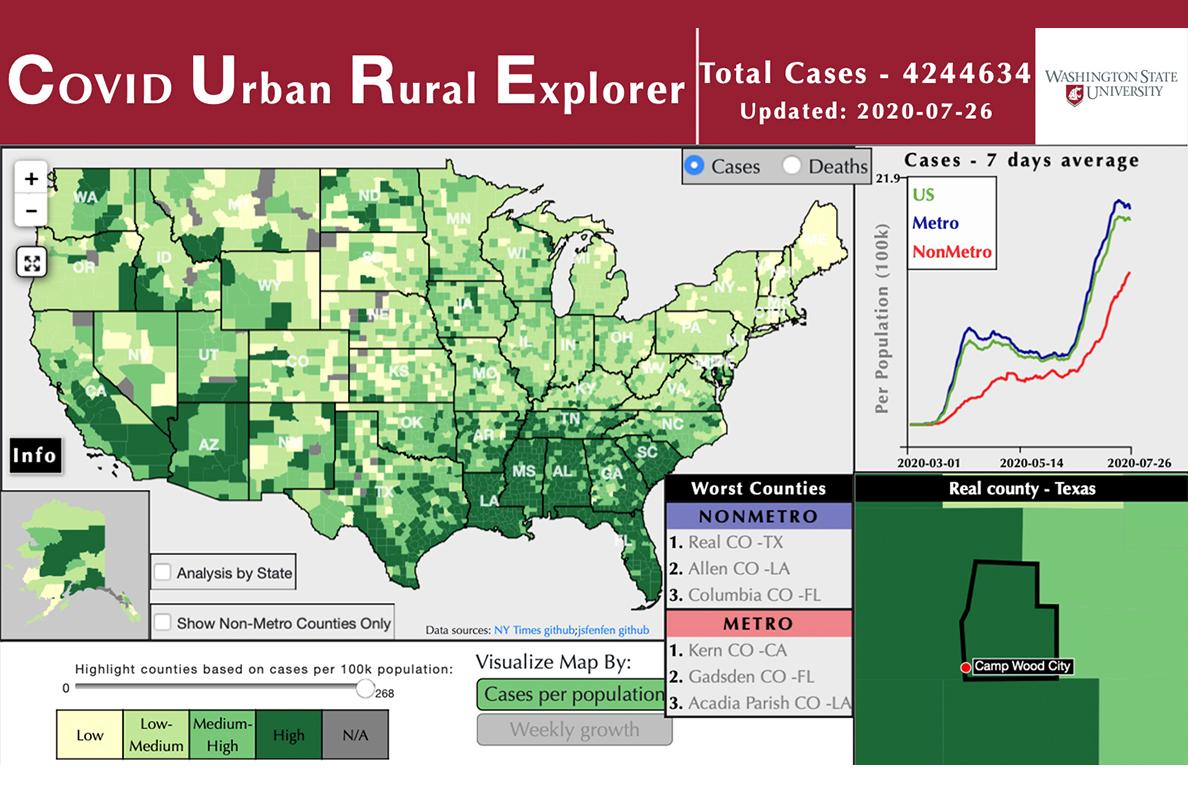Draw attention to some important aspects in this diagram. In the United States, the metropolitan area is more significantly affected than the non-metropolitan area. The green line in the graph representing cases over a 7-day average indicates the region. The blue line in the graph represents the average cases over a 7-day period for a specific region, and it is Metro that is indicated by the line. 